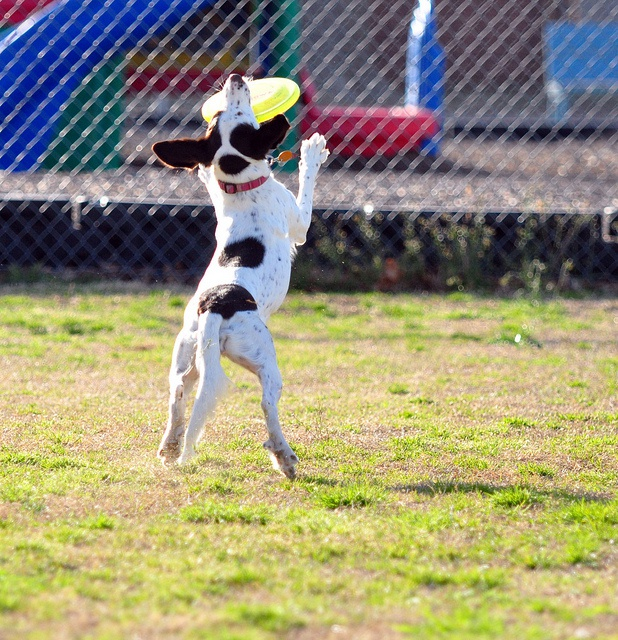Describe the objects in this image and their specific colors. I can see dog in lightpink, darkgray, white, and black tones and frisbee in lightpink, ivory, yellow, and khaki tones in this image. 